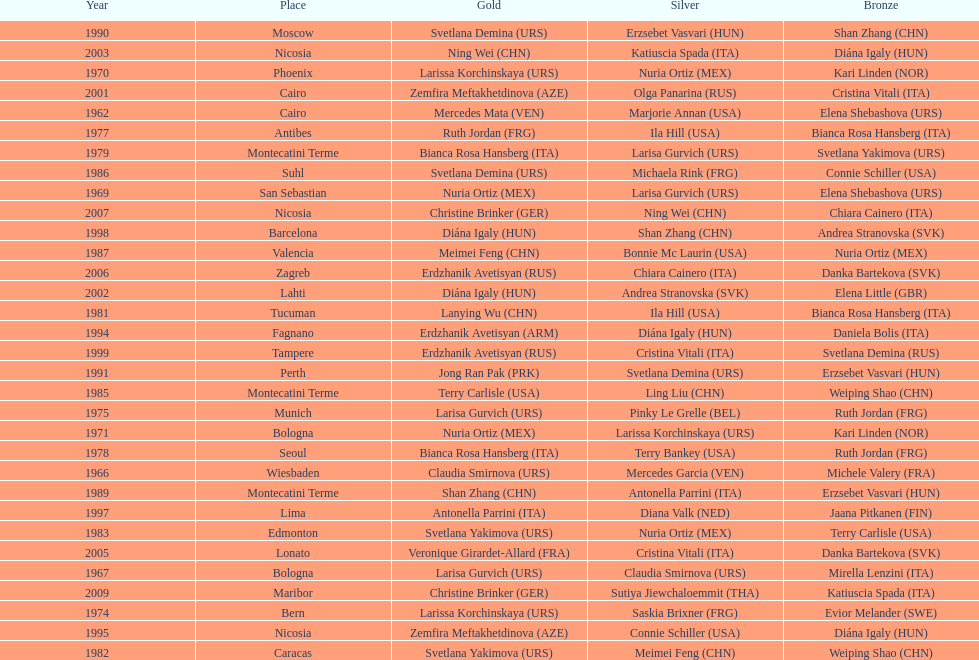Which country has the most bronze medals? Italy. 